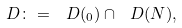Convert formula to latex. <formula><loc_0><loc_0><loc_500><loc_500>\ D \colon = \ D ( \L _ { 0 } ) \cap \ D ( N ) ,</formula> 